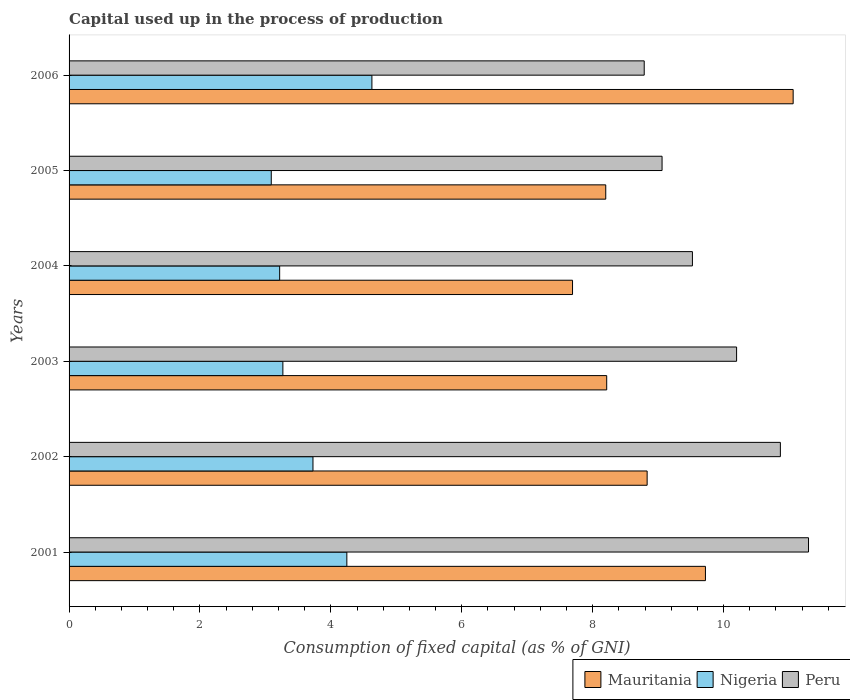How many bars are there on the 6th tick from the top?
Ensure brevity in your answer.  3. How many bars are there on the 4th tick from the bottom?
Provide a succinct answer. 3. What is the label of the 6th group of bars from the top?
Provide a succinct answer. 2001. In how many cases, is the number of bars for a given year not equal to the number of legend labels?
Your response must be concise. 0. What is the capital used up in the process of production in Nigeria in 2003?
Provide a succinct answer. 3.27. Across all years, what is the maximum capital used up in the process of production in Mauritania?
Offer a terse response. 11.06. Across all years, what is the minimum capital used up in the process of production in Mauritania?
Your answer should be very brief. 7.69. In which year was the capital used up in the process of production in Mauritania minimum?
Make the answer very short. 2004. What is the total capital used up in the process of production in Nigeria in the graph?
Your answer should be compact. 22.17. What is the difference between the capital used up in the process of production in Nigeria in 2001 and that in 2005?
Offer a very short reply. 1.15. What is the difference between the capital used up in the process of production in Peru in 2004 and the capital used up in the process of production in Nigeria in 2002?
Provide a short and direct response. 5.8. What is the average capital used up in the process of production in Peru per year?
Give a very brief answer. 9.96. In the year 2006, what is the difference between the capital used up in the process of production in Mauritania and capital used up in the process of production in Peru?
Ensure brevity in your answer.  2.28. In how many years, is the capital used up in the process of production in Mauritania greater than 2 %?
Give a very brief answer. 6. What is the ratio of the capital used up in the process of production in Nigeria in 2002 to that in 2006?
Provide a short and direct response. 0.81. Is the capital used up in the process of production in Mauritania in 2002 less than that in 2004?
Make the answer very short. No. Is the difference between the capital used up in the process of production in Mauritania in 2003 and 2006 greater than the difference between the capital used up in the process of production in Peru in 2003 and 2006?
Give a very brief answer. No. What is the difference between the highest and the second highest capital used up in the process of production in Nigeria?
Provide a succinct answer. 0.38. What is the difference between the highest and the lowest capital used up in the process of production in Nigeria?
Provide a short and direct response. 1.54. In how many years, is the capital used up in the process of production in Mauritania greater than the average capital used up in the process of production in Mauritania taken over all years?
Your answer should be very brief. 2. What does the 3rd bar from the top in 2002 represents?
Your response must be concise. Mauritania. What does the 1st bar from the bottom in 2006 represents?
Make the answer very short. Mauritania. Is it the case that in every year, the sum of the capital used up in the process of production in Peru and capital used up in the process of production in Nigeria is greater than the capital used up in the process of production in Mauritania?
Provide a short and direct response. Yes. How many bars are there?
Your response must be concise. 18. Are all the bars in the graph horizontal?
Your answer should be very brief. Yes. What is the difference between two consecutive major ticks on the X-axis?
Make the answer very short. 2. Are the values on the major ticks of X-axis written in scientific E-notation?
Offer a terse response. No. Does the graph contain grids?
Keep it short and to the point. No. How are the legend labels stacked?
Give a very brief answer. Horizontal. What is the title of the graph?
Your answer should be very brief. Capital used up in the process of production. Does "Fragile and conflict affected situations" appear as one of the legend labels in the graph?
Provide a short and direct response. No. What is the label or title of the X-axis?
Your response must be concise. Consumption of fixed capital (as % of GNI). What is the label or title of the Y-axis?
Your answer should be very brief. Years. What is the Consumption of fixed capital (as % of GNI) in Mauritania in 2001?
Give a very brief answer. 9.72. What is the Consumption of fixed capital (as % of GNI) of Nigeria in 2001?
Make the answer very short. 4.24. What is the Consumption of fixed capital (as % of GNI) of Peru in 2001?
Give a very brief answer. 11.3. What is the Consumption of fixed capital (as % of GNI) of Mauritania in 2002?
Your answer should be compact. 8.83. What is the Consumption of fixed capital (as % of GNI) in Nigeria in 2002?
Provide a short and direct response. 3.73. What is the Consumption of fixed capital (as % of GNI) of Peru in 2002?
Provide a succinct answer. 10.87. What is the Consumption of fixed capital (as % of GNI) of Mauritania in 2003?
Make the answer very short. 8.21. What is the Consumption of fixed capital (as % of GNI) in Nigeria in 2003?
Give a very brief answer. 3.27. What is the Consumption of fixed capital (as % of GNI) in Peru in 2003?
Keep it short and to the point. 10.2. What is the Consumption of fixed capital (as % of GNI) in Mauritania in 2004?
Your response must be concise. 7.69. What is the Consumption of fixed capital (as % of GNI) in Nigeria in 2004?
Ensure brevity in your answer.  3.22. What is the Consumption of fixed capital (as % of GNI) in Peru in 2004?
Make the answer very short. 9.52. What is the Consumption of fixed capital (as % of GNI) in Mauritania in 2005?
Keep it short and to the point. 8.2. What is the Consumption of fixed capital (as % of GNI) of Nigeria in 2005?
Offer a terse response. 3.09. What is the Consumption of fixed capital (as % of GNI) in Peru in 2005?
Provide a short and direct response. 9.06. What is the Consumption of fixed capital (as % of GNI) of Mauritania in 2006?
Offer a terse response. 11.06. What is the Consumption of fixed capital (as % of GNI) in Nigeria in 2006?
Provide a short and direct response. 4.63. What is the Consumption of fixed capital (as % of GNI) in Peru in 2006?
Make the answer very short. 8.79. Across all years, what is the maximum Consumption of fixed capital (as % of GNI) of Mauritania?
Provide a short and direct response. 11.06. Across all years, what is the maximum Consumption of fixed capital (as % of GNI) in Nigeria?
Offer a terse response. 4.63. Across all years, what is the maximum Consumption of fixed capital (as % of GNI) of Peru?
Offer a very short reply. 11.3. Across all years, what is the minimum Consumption of fixed capital (as % of GNI) of Mauritania?
Keep it short and to the point. 7.69. Across all years, what is the minimum Consumption of fixed capital (as % of GNI) in Nigeria?
Offer a terse response. 3.09. Across all years, what is the minimum Consumption of fixed capital (as % of GNI) in Peru?
Your response must be concise. 8.79. What is the total Consumption of fixed capital (as % of GNI) of Mauritania in the graph?
Your answer should be compact. 53.73. What is the total Consumption of fixed capital (as % of GNI) in Nigeria in the graph?
Keep it short and to the point. 22.17. What is the total Consumption of fixed capital (as % of GNI) of Peru in the graph?
Your answer should be compact. 59.74. What is the difference between the Consumption of fixed capital (as % of GNI) of Mauritania in 2001 and that in 2002?
Offer a terse response. 0.89. What is the difference between the Consumption of fixed capital (as % of GNI) of Nigeria in 2001 and that in 2002?
Make the answer very short. 0.52. What is the difference between the Consumption of fixed capital (as % of GNI) in Peru in 2001 and that in 2002?
Give a very brief answer. 0.43. What is the difference between the Consumption of fixed capital (as % of GNI) of Mauritania in 2001 and that in 2003?
Offer a terse response. 1.51. What is the difference between the Consumption of fixed capital (as % of GNI) of Nigeria in 2001 and that in 2003?
Provide a succinct answer. 0.98. What is the difference between the Consumption of fixed capital (as % of GNI) of Peru in 2001 and that in 2003?
Give a very brief answer. 1.1. What is the difference between the Consumption of fixed capital (as % of GNI) of Mauritania in 2001 and that in 2004?
Offer a very short reply. 2.03. What is the difference between the Consumption of fixed capital (as % of GNI) of Nigeria in 2001 and that in 2004?
Keep it short and to the point. 1.03. What is the difference between the Consumption of fixed capital (as % of GNI) in Peru in 2001 and that in 2004?
Your answer should be very brief. 1.77. What is the difference between the Consumption of fixed capital (as % of GNI) in Mauritania in 2001 and that in 2005?
Offer a terse response. 1.52. What is the difference between the Consumption of fixed capital (as % of GNI) of Nigeria in 2001 and that in 2005?
Make the answer very short. 1.15. What is the difference between the Consumption of fixed capital (as % of GNI) of Peru in 2001 and that in 2005?
Give a very brief answer. 2.24. What is the difference between the Consumption of fixed capital (as % of GNI) in Mauritania in 2001 and that in 2006?
Make the answer very short. -1.34. What is the difference between the Consumption of fixed capital (as % of GNI) of Nigeria in 2001 and that in 2006?
Your answer should be very brief. -0.38. What is the difference between the Consumption of fixed capital (as % of GNI) of Peru in 2001 and that in 2006?
Give a very brief answer. 2.51. What is the difference between the Consumption of fixed capital (as % of GNI) of Mauritania in 2002 and that in 2003?
Offer a terse response. 0.62. What is the difference between the Consumption of fixed capital (as % of GNI) of Nigeria in 2002 and that in 2003?
Make the answer very short. 0.46. What is the difference between the Consumption of fixed capital (as % of GNI) in Peru in 2002 and that in 2003?
Your response must be concise. 0.67. What is the difference between the Consumption of fixed capital (as % of GNI) in Mauritania in 2002 and that in 2004?
Keep it short and to the point. 1.14. What is the difference between the Consumption of fixed capital (as % of GNI) in Nigeria in 2002 and that in 2004?
Give a very brief answer. 0.51. What is the difference between the Consumption of fixed capital (as % of GNI) in Peru in 2002 and that in 2004?
Provide a short and direct response. 1.34. What is the difference between the Consumption of fixed capital (as % of GNI) in Mauritania in 2002 and that in 2005?
Offer a very short reply. 0.63. What is the difference between the Consumption of fixed capital (as % of GNI) of Nigeria in 2002 and that in 2005?
Provide a succinct answer. 0.64. What is the difference between the Consumption of fixed capital (as % of GNI) in Peru in 2002 and that in 2005?
Provide a short and direct response. 1.81. What is the difference between the Consumption of fixed capital (as % of GNI) of Mauritania in 2002 and that in 2006?
Provide a short and direct response. -2.23. What is the difference between the Consumption of fixed capital (as % of GNI) in Nigeria in 2002 and that in 2006?
Provide a succinct answer. -0.9. What is the difference between the Consumption of fixed capital (as % of GNI) in Peru in 2002 and that in 2006?
Keep it short and to the point. 2.08. What is the difference between the Consumption of fixed capital (as % of GNI) in Mauritania in 2003 and that in 2004?
Offer a terse response. 0.52. What is the difference between the Consumption of fixed capital (as % of GNI) of Nigeria in 2003 and that in 2004?
Ensure brevity in your answer.  0.05. What is the difference between the Consumption of fixed capital (as % of GNI) of Peru in 2003 and that in 2004?
Offer a very short reply. 0.67. What is the difference between the Consumption of fixed capital (as % of GNI) in Mauritania in 2003 and that in 2005?
Provide a succinct answer. 0.01. What is the difference between the Consumption of fixed capital (as % of GNI) of Nigeria in 2003 and that in 2005?
Offer a very short reply. 0.18. What is the difference between the Consumption of fixed capital (as % of GNI) of Peru in 2003 and that in 2005?
Ensure brevity in your answer.  1.14. What is the difference between the Consumption of fixed capital (as % of GNI) in Mauritania in 2003 and that in 2006?
Your answer should be compact. -2.85. What is the difference between the Consumption of fixed capital (as % of GNI) of Nigeria in 2003 and that in 2006?
Offer a terse response. -1.36. What is the difference between the Consumption of fixed capital (as % of GNI) of Peru in 2003 and that in 2006?
Offer a terse response. 1.41. What is the difference between the Consumption of fixed capital (as % of GNI) of Mauritania in 2004 and that in 2005?
Provide a short and direct response. -0.51. What is the difference between the Consumption of fixed capital (as % of GNI) of Nigeria in 2004 and that in 2005?
Your response must be concise. 0.13. What is the difference between the Consumption of fixed capital (as % of GNI) of Peru in 2004 and that in 2005?
Give a very brief answer. 0.46. What is the difference between the Consumption of fixed capital (as % of GNI) of Mauritania in 2004 and that in 2006?
Your answer should be very brief. -3.37. What is the difference between the Consumption of fixed capital (as % of GNI) in Nigeria in 2004 and that in 2006?
Provide a short and direct response. -1.41. What is the difference between the Consumption of fixed capital (as % of GNI) of Peru in 2004 and that in 2006?
Make the answer very short. 0.74. What is the difference between the Consumption of fixed capital (as % of GNI) of Mauritania in 2005 and that in 2006?
Make the answer very short. -2.86. What is the difference between the Consumption of fixed capital (as % of GNI) of Nigeria in 2005 and that in 2006?
Offer a very short reply. -1.54. What is the difference between the Consumption of fixed capital (as % of GNI) of Peru in 2005 and that in 2006?
Your response must be concise. 0.27. What is the difference between the Consumption of fixed capital (as % of GNI) of Mauritania in 2001 and the Consumption of fixed capital (as % of GNI) of Nigeria in 2002?
Provide a short and direct response. 6. What is the difference between the Consumption of fixed capital (as % of GNI) in Mauritania in 2001 and the Consumption of fixed capital (as % of GNI) in Peru in 2002?
Provide a succinct answer. -1.14. What is the difference between the Consumption of fixed capital (as % of GNI) of Nigeria in 2001 and the Consumption of fixed capital (as % of GNI) of Peru in 2002?
Provide a succinct answer. -6.62. What is the difference between the Consumption of fixed capital (as % of GNI) in Mauritania in 2001 and the Consumption of fixed capital (as % of GNI) in Nigeria in 2003?
Offer a terse response. 6.46. What is the difference between the Consumption of fixed capital (as % of GNI) of Mauritania in 2001 and the Consumption of fixed capital (as % of GNI) of Peru in 2003?
Offer a terse response. -0.48. What is the difference between the Consumption of fixed capital (as % of GNI) of Nigeria in 2001 and the Consumption of fixed capital (as % of GNI) of Peru in 2003?
Your response must be concise. -5.96. What is the difference between the Consumption of fixed capital (as % of GNI) of Mauritania in 2001 and the Consumption of fixed capital (as % of GNI) of Nigeria in 2004?
Give a very brief answer. 6.51. What is the difference between the Consumption of fixed capital (as % of GNI) in Mauritania in 2001 and the Consumption of fixed capital (as % of GNI) in Peru in 2004?
Your response must be concise. 0.2. What is the difference between the Consumption of fixed capital (as % of GNI) in Nigeria in 2001 and the Consumption of fixed capital (as % of GNI) in Peru in 2004?
Your answer should be very brief. -5.28. What is the difference between the Consumption of fixed capital (as % of GNI) of Mauritania in 2001 and the Consumption of fixed capital (as % of GNI) of Nigeria in 2005?
Your answer should be very brief. 6.63. What is the difference between the Consumption of fixed capital (as % of GNI) in Mauritania in 2001 and the Consumption of fixed capital (as % of GNI) in Peru in 2005?
Your answer should be compact. 0.66. What is the difference between the Consumption of fixed capital (as % of GNI) of Nigeria in 2001 and the Consumption of fixed capital (as % of GNI) of Peru in 2005?
Offer a terse response. -4.82. What is the difference between the Consumption of fixed capital (as % of GNI) in Mauritania in 2001 and the Consumption of fixed capital (as % of GNI) in Nigeria in 2006?
Ensure brevity in your answer.  5.1. What is the difference between the Consumption of fixed capital (as % of GNI) of Mauritania in 2001 and the Consumption of fixed capital (as % of GNI) of Peru in 2006?
Offer a very short reply. 0.94. What is the difference between the Consumption of fixed capital (as % of GNI) of Nigeria in 2001 and the Consumption of fixed capital (as % of GNI) of Peru in 2006?
Provide a short and direct response. -4.54. What is the difference between the Consumption of fixed capital (as % of GNI) in Mauritania in 2002 and the Consumption of fixed capital (as % of GNI) in Nigeria in 2003?
Provide a short and direct response. 5.57. What is the difference between the Consumption of fixed capital (as % of GNI) in Mauritania in 2002 and the Consumption of fixed capital (as % of GNI) in Peru in 2003?
Your answer should be very brief. -1.37. What is the difference between the Consumption of fixed capital (as % of GNI) of Nigeria in 2002 and the Consumption of fixed capital (as % of GNI) of Peru in 2003?
Provide a succinct answer. -6.47. What is the difference between the Consumption of fixed capital (as % of GNI) in Mauritania in 2002 and the Consumption of fixed capital (as % of GNI) in Nigeria in 2004?
Make the answer very short. 5.62. What is the difference between the Consumption of fixed capital (as % of GNI) of Mauritania in 2002 and the Consumption of fixed capital (as % of GNI) of Peru in 2004?
Keep it short and to the point. -0.69. What is the difference between the Consumption of fixed capital (as % of GNI) in Nigeria in 2002 and the Consumption of fixed capital (as % of GNI) in Peru in 2004?
Give a very brief answer. -5.8. What is the difference between the Consumption of fixed capital (as % of GNI) in Mauritania in 2002 and the Consumption of fixed capital (as % of GNI) in Nigeria in 2005?
Offer a very short reply. 5.74. What is the difference between the Consumption of fixed capital (as % of GNI) in Mauritania in 2002 and the Consumption of fixed capital (as % of GNI) in Peru in 2005?
Provide a short and direct response. -0.23. What is the difference between the Consumption of fixed capital (as % of GNI) of Nigeria in 2002 and the Consumption of fixed capital (as % of GNI) of Peru in 2005?
Your answer should be very brief. -5.33. What is the difference between the Consumption of fixed capital (as % of GNI) in Mauritania in 2002 and the Consumption of fixed capital (as % of GNI) in Nigeria in 2006?
Offer a terse response. 4.21. What is the difference between the Consumption of fixed capital (as % of GNI) in Mauritania in 2002 and the Consumption of fixed capital (as % of GNI) in Peru in 2006?
Ensure brevity in your answer.  0.04. What is the difference between the Consumption of fixed capital (as % of GNI) in Nigeria in 2002 and the Consumption of fixed capital (as % of GNI) in Peru in 2006?
Your answer should be very brief. -5.06. What is the difference between the Consumption of fixed capital (as % of GNI) of Mauritania in 2003 and the Consumption of fixed capital (as % of GNI) of Nigeria in 2004?
Offer a very short reply. 5. What is the difference between the Consumption of fixed capital (as % of GNI) of Mauritania in 2003 and the Consumption of fixed capital (as % of GNI) of Peru in 2004?
Your response must be concise. -1.31. What is the difference between the Consumption of fixed capital (as % of GNI) of Nigeria in 2003 and the Consumption of fixed capital (as % of GNI) of Peru in 2004?
Your response must be concise. -6.26. What is the difference between the Consumption of fixed capital (as % of GNI) of Mauritania in 2003 and the Consumption of fixed capital (as % of GNI) of Nigeria in 2005?
Give a very brief answer. 5.13. What is the difference between the Consumption of fixed capital (as % of GNI) in Mauritania in 2003 and the Consumption of fixed capital (as % of GNI) in Peru in 2005?
Make the answer very short. -0.85. What is the difference between the Consumption of fixed capital (as % of GNI) in Nigeria in 2003 and the Consumption of fixed capital (as % of GNI) in Peru in 2005?
Make the answer very short. -5.79. What is the difference between the Consumption of fixed capital (as % of GNI) of Mauritania in 2003 and the Consumption of fixed capital (as % of GNI) of Nigeria in 2006?
Offer a terse response. 3.59. What is the difference between the Consumption of fixed capital (as % of GNI) in Mauritania in 2003 and the Consumption of fixed capital (as % of GNI) in Peru in 2006?
Your response must be concise. -0.57. What is the difference between the Consumption of fixed capital (as % of GNI) in Nigeria in 2003 and the Consumption of fixed capital (as % of GNI) in Peru in 2006?
Your response must be concise. -5.52. What is the difference between the Consumption of fixed capital (as % of GNI) of Mauritania in 2004 and the Consumption of fixed capital (as % of GNI) of Nigeria in 2005?
Make the answer very short. 4.6. What is the difference between the Consumption of fixed capital (as % of GNI) of Mauritania in 2004 and the Consumption of fixed capital (as % of GNI) of Peru in 2005?
Provide a succinct answer. -1.37. What is the difference between the Consumption of fixed capital (as % of GNI) of Nigeria in 2004 and the Consumption of fixed capital (as % of GNI) of Peru in 2005?
Provide a succinct answer. -5.84. What is the difference between the Consumption of fixed capital (as % of GNI) in Mauritania in 2004 and the Consumption of fixed capital (as % of GNI) in Nigeria in 2006?
Provide a succinct answer. 3.07. What is the difference between the Consumption of fixed capital (as % of GNI) in Mauritania in 2004 and the Consumption of fixed capital (as % of GNI) in Peru in 2006?
Provide a succinct answer. -1.1. What is the difference between the Consumption of fixed capital (as % of GNI) in Nigeria in 2004 and the Consumption of fixed capital (as % of GNI) in Peru in 2006?
Your answer should be compact. -5.57. What is the difference between the Consumption of fixed capital (as % of GNI) of Mauritania in 2005 and the Consumption of fixed capital (as % of GNI) of Nigeria in 2006?
Provide a short and direct response. 3.57. What is the difference between the Consumption of fixed capital (as % of GNI) of Mauritania in 2005 and the Consumption of fixed capital (as % of GNI) of Peru in 2006?
Provide a succinct answer. -0.59. What is the difference between the Consumption of fixed capital (as % of GNI) in Nigeria in 2005 and the Consumption of fixed capital (as % of GNI) in Peru in 2006?
Provide a short and direct response. -5.7. What is the average Consumption of fixed capital (as % of GNI) of Mauritania per year?
Ensure brevity in your answer.  8.95. What is the average Consumption of fixed capital (as % of GNI) of Nigeria per year?
Keep it short and to the point. 3.7. What is the average Consumption of fixed capital (as % of GNI) of Peru per year?
Ensure brevity in your answer.  9.96. In the year 2001, what is the difference between the Consumption of fixed capital (as % of GNI) of Mauritania and Consumption of fixed capital (as % of GNI) of Nigeria?
Ensure brevity in your answer.  5.48. In the year 2001, what is the difference between the Consumption of fixed capital (as % of GNI) in Mauritania and Consumption of fixed capital (as % of GNI) in Peru?
Provide a succinct answer. -1.57. In the year 2001, what is the difference between the Consumption of fixed capital (as % of GNI) in Nigeria and Consumption of fixed capital (as % of GNI) in Peru?
Make the answer very short. -7.05. In the year 2002, what is the difference between the Consumption of fixed capital (as % of GNI) in Mauritania and Consumption of fixed capital (as % of GNI) in Nigeria?
Your answer should be compact. 5.11. In the year 2002, what is the difference between the Consumption of fixed capital (as % of GNI) in Mauritania and Consumption of fixed capital (as % of GNI) in Peru?
Ensure brevity in your answer.  -2.04. In the year 2002, what is the difference between the Consumption of fixed capital (as % of GNI) in Nigeria and Consumption of fixed capital (as % of GNI) in Peru?
Ensure brevity in your answer.  -7.14. In the year 2003, what is the difference between the Consumption of fixed capital (as % of GNI) in Mauritania and Consumption of fixed capital (as % of GNI) in Nigeria?
Your answer should be compact. 4.95. In the year 2003, what is the difference between the Consumption of fixed capital (as % of GNI) in Mauritania and Consumption of fixed capital (as % of GNI) in Peru?
Your answer should be very brief. -1.98. In the year 2003, what is the difference between the Consumption of fixed capital (as % of GNI) in Nigeria and Consumption of fixed capital (as % of GNI) in Peru?
Offer a very short reply. -6.93. In the year 2004, what is the difference between the Consumption of fixed capital (as % of GNI) in Mauritania and Consumption of fixed capital (as % of GNI) in Nigeria?
Your answer should be very brief. 4.47. In the year 2004, what is the difference between the Consumption of fixed capital (as % of GNI) of Mauritania and Consumption of fixed capital (as % of GNI) of Peru?
Ensure brevity in your answer.  -1.83. In the year 2004, what is the difference between the Consumption of fixed capital (as % of GNI) in Nigeria and Consumption of fixed capital (as % of GNI) in Peru?
Provide a succinct answer. -6.31. In the year 2005, what is the difference between the Consumption of fixed capital (as % of GNI) in Mauritania and Consumption of fixed capital (as % of GNI) in Nigeria?
Your answer should be compact. 5.11. In the year 2005, what is the difference between the Consumption of fixed capital (as % of GNI) in Mauritania and Consumption of fixed capital (as % of GNI) in Peru?
Your answer should be compact. -0.86. In the year 2005, what is the difference between the Consumption of fixed capital (as % of GNI) in Nigeria and Consumption of fixed capital (as % of GNI) in Peru?
Give a very brief answer. -5.97. In the year 2006, what is the difference between the Consumption of fixed capital (as % of GNI) of Mauritania and Consumption of fixed capital (as % of GNI) of Nigeria?
Provide a short and direct response. 6.44. In the year 2006, what is the difference between the Consumption of fixed capital (as % of GNI) of Mauritania and Consumption of fixed capital (as % of GNI) of Peru?
Ensure brevity in your answer.  2.28. In the year 2006, what is the difference between the Consumption of fixed capital (as % of GNI) in Nigeria and Consumption of fixed capital (as % of GNI) in Peru?
Keep it short and to the point. -4.16. What is the ratio of the Consumption of fixed capital (as % of GNI) of Mauritania in 2001 to that in 2002?
Offer a very short reply. 1.1. What is the ratio of the Consumption of fixed capital (as % of GNI) of Nigeria in 2001 to that in 2002?
Ensure brevity in your answer.  1.14. What is the ratio of the Consumption of fixed capital (as % of GNI) of Peru in 2001 to that in 2002?
Ensure brevity in your answer.  1.04. What is the ratio of the Consumption of fixed capital (as % of GNI) in Mauritania in 2001 to that in 2003?
Give a very brief answer. 1.18. What is the ratio of the Consumption of fixed capital (as % of GNI) of Nigeria in 2001 to that in 2003?
Give a very brief answer. 1.3. What is the ratio of the Consumption of fixed capital (as % of GNI) of Peru in 2001 to that in 2003?
Offer a terse response. 1.11. What is the ratio of the Consumption of fixed capital (as % of GNI) of Mauritania in 2001 to that in 2004?
Keep it short and to the point. 1.26. What is the ratio of the Consumption of fixed capital (as % of GNI) in Nigeria in 2001 to that in 2004?
Offer a very short reply. 1.32. What is the ratio of the Consumption of fixed capital (as % of GNI) of Peru in 2001 to that in 2004?
Keep it short and to the point. 1.19. What is the ratio of the Consumption of fixed capital (as % of GNI) of Mauritania in 2001 to that in 2005?
Make the answer very short. 1.19. What is the ratio of the Consumption of fixed capital (as % of GNI) of Nigeria in 2001 to that in 2005?
Your answer should be compact. 1.37. What is the ratio of the Consumption of fixed capital (as % of GNI) of Peru in 2001 to that in 2005?
Provide a succinct answer. 1.25. What is the ratio of the Consumption of fixed capital (as % of GNI) of Mauritania in 2001 to that in 2006?
Keep it short and to the point. 0.88. What is the ratio of the Consumption of fixed capital (as % of GNI) of Nigeria in 2001 to that in 2006?
Provide a short and direct response. 0.92. What is the ratio of the Consumption of fixed capital (as % of GNI) in Mauritania in 2002 to that in 2003?
Your answer should be compact. 1.08. What is the ratio of the Consumption of fixed capital (as % of GNI) of Nigeria in 2002 to that in 2003?
Your response must be concise. 1.14. What is the ratio of the Consumption of fixed capital (as % of GNI) of Peru in 2002 to that in 2003?
Give a very brief answer. 1.07. What is the ratio of the Consumption of fixed capital (as % of GNI) in Mauritania in 2002 to that in 2004?
Ensure brevity in your answer.  1.15. What is the ratio of the Consumption of fixed capital (as % of GNI) of Nigeria in 2002 to that in 2004?
Give a very brief answer. 1.16. What is the ratio of the Consumption of fixed capital (as % of GNI) in Peru in 2002 to that in 2004?
Your answer should be compact. 1.14. What is the ratio of the Consumption of fixed capital (as % of GNI) in Mauritania in 2002 to that in 2005?
Make the answer very short. 1.08. What is the ratio of the Consumption of fixed capital (as % of GNI) in Nigeria in 2002 to that in 2005?
Your answer should be compact. 1.21. What is the ratio of the Consumption of fixed capital (as % of GNI) in Peru in 2002 to that in 2005?
Your answer should be compact. 1.2. What is the ratio of the Consumption of fixed capital (as % of GNI) in Mauritania in 2002 to that in 2006?
Ensure brevity in your answer.  0.8. What is the ratio of the Consumption of fixed capital (as % of GNI) in Nigeria in 2002 to that in 2006?
Give a very brief answer. 0.81. What is the ratio of the Consumption of fixed capital (as % of GNI) of Peru in 2002 to that in 2006?
Keep it short and to the point. 1.24. What is the ratio of the Consumption of fixed capital (as % of GNI) in Mauritania in 2003 to that in 2004?
Provide a short and direct response. 1.07. What is the ratio of the Consumption of fixed capital (as % of GNI) of Nigeria in 2003 to that in 2004?
Your answer should be compact. 1.02. What is the ratio of the Consumption of fixed capital (as % of GNI) in Peru in 2003 to that in 2004?
Your response must be concise. 1.07. What is the ratio of the Consumption of fixed capital (as % of GNI) in Nigeria in 2003 to that in 2005?
Your answer should be compact. 1.06. What is the ratio of the Consumption of fixed capital (as % of GNI) in Peru in 2003 to that in 2005?
Ensure brevity in your answer.  1.13. What is the ratio of the Consumption of fixed capital (as % of GNI) in Mauritania in 2003 to that in 2006?
Your answer should be very brief. 0.74. What is the ratio of the Consumption of fixed capital (as % of GNI) of Nigeria in 2003 to that in 2006?
Offer a terse response. 0.71. What is the ratio of the Consumption of fixed capital (as % of GNI) in Peru in 2003 to that in 2006?
Provide a succinct answer. 1.16. What is the ratio of the Consumption of fixed capital (as % of GNI) of Mauritania in 2004 to that in 2005?
Ensure brevity in your answer.  0.94. What is the ratio of the Consumption of fixed capital (as % of GNI) in Nigeria in 2004 to that in 2005?
Your response must be concise. 1.04. What is the ratio of the Consumption of fixed capital (as % of GNI) in Peru in 2004 to that in 2005?
Provide a short and direct response. 1.05. What is the ratio of the Consumption of fixed capital (as % of GNI) of Mauritania in 2004 to that in 2006?
Offer a terse response. 0.7. What is the ratio of the Consumption of fixed capital (as % of GNI) of Nigeria in 2004 to that in 2006?
Make the answer very short. 0.7. What is the ratio of the Consumption of fixed capital (as % of GNI) of Peru in 2004 to that in 2006?
Your response must be concise. 1.08. What is the ratio of the Consumption of fixed capital (as % of GNI) in Mauritania in 2005 to that in 2006?
Make the answer very short. 0.74. What is the ratio of the Consumption of fixed capital (as % of GNI) of Nigeria in 2005 to that in 2006?
Your response must be concise. 0.67. What is the ratio of the Consumption of fixed capital (as % of GNI) in Peru in 2005 to that in 2006?
Provide a succinct answer. 1.03. What is the difference between the highest and the second highest Consumption of fixed capital (as % of GNI) of Mauritania?
Your answer should be compact. 1.34. What is the difference between the highest and the second highest Consumption of fixed capital (as % of GNI) in Nigeria?
Make the answer very short. 0.38. What is the difference between the highest and the second highest Consumption of fixed capital (as % of GNI) of Peru?
Your answer should be compact. 0.43. What is the difference between the highest and the lowest Consumption of fixed capital (as % of GNI) of Mauritania?
Keep it short and to the point. 3.37. What is the difference between the highest and the lowest Consumption of fixed capital (as % of GNI) in Nigeria?
Keep it short and to the point. 1.54. What is the difference between the highest and the lowest Consumption of fixed capital (as % of GNI) in Peru?
Keep it short and to the point. 2.51. 